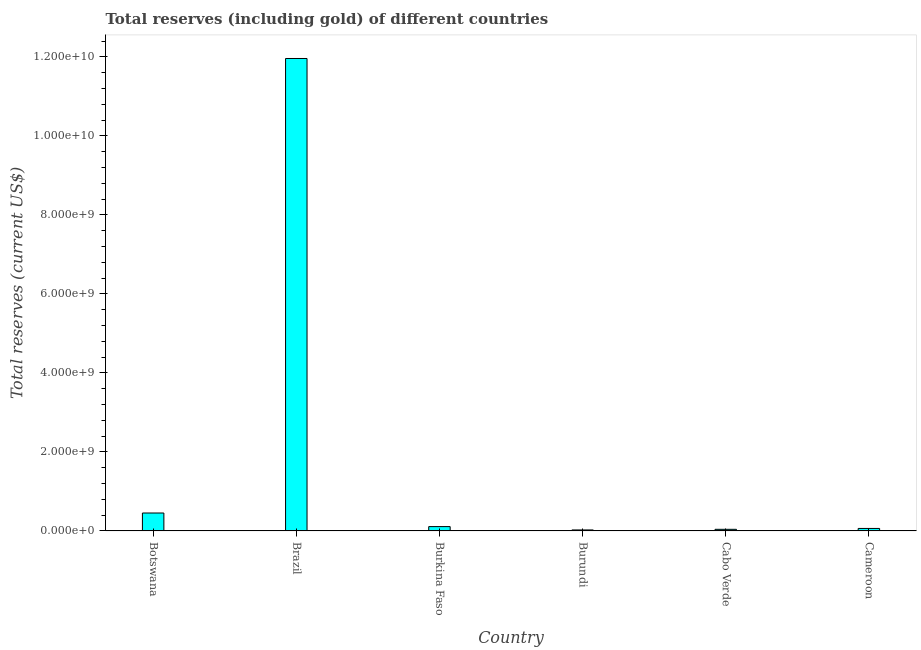Does the graph contain any zero values?
Offer a terse response. No. What is the title of the graph?
Ensure brevity in your answer.  Total reserves (including gold) of different countries. What is the label or title of the X-axis?
Provide a short and direct response. Country. What is the label or title of the Y-axis?
Make the answer very short. Total reserves (current US$). What is the total reserves (including gold) in Burkina Faso?
Keep it short and to the point. 1.10e+08. Across all countries, what is the maximum total reserves (including gold)?
Provide a succinct answer. 1.20e+1. Across all countries, what is the minimum total reserves (including gold)?
Your answer should be very brief. 2.50e+07. In which country was the total reserves (including gold) maximum?
Keep it short and to the point. Brazil. In which country was the total reserves (including gold) minimum?
Ensure brevity in your answer.  Burundi. What is the sum of the total reserves (including gold)?
Your answer should be very brief. 1.27e+1. What is the difference between the total reserves (including gold) in Burkina Faso and Cameroon?
Keep it short and to the point. 4.66e+07. What is the average total reserves (including gold) per country?
Your answer should be compact. 2.11e+09. What is the median total reserves (including gold)?
Your answer should be very brief. 8.64e+07. In how many countries, is the total reserves (including gold) greater than 400000000 US$?
Provide a succinct answer. 2. What is the ratio of the total reserves (including gold) in Burundi to that in Cabo Verde?
Make the answer very short. 0.61. Is the difference between the total reserves (including gold) in Brazil and Cameroon greater than the difference between any two countries?
Keep it short and to the point. No. What is the difference between the highest and the second highest total reserves (including gold)?
Your response must be concise. 1.15e+1. Is the sum of the total reserves (including gold) in Botswana and Cameroon greater than the maximum total reserves (including gold) across all countries?
Keep it short and to the point. No. What is the difference between the highest and the lowest total reserves (including gold)?
Your answer should be very brief. 1.19e+1. In how many countries, is the total reserves (including gold) greater than the average total reserves (including gold) taken over all countries?
Your response must be concise. 1. Are all the bars in the graph horizontal?
Your response must be concise. No. What is the Total reserves (current US$) of Botswana?
Provide a succinct answer. 4.54e+08. What is the Total reserves (current US$) in Brazil?
Offer a terse response. 1.20e+1. What is the Total reserves (current US$) of Burkina Faso?
Make the answer very short. 1.10e+08. What is the Total reserves (current US$) in Burundi?
Your answer should be very brief. 2.50e+07. What is the Total reserves (current US$) of Cabo Verde?
Provide a succinct answer. 4.10e+07. What is the Total reserves (current US$) in Cameroon?
Keep it short and to the point. 6.31e+07. What is the difference between the Total reserves (current US$) in Botswana and Brazil?
Your response must be concise. -1.15e+1. What is the difference between the Total reserves (current US$) in Botswana and Burkina Faso?
Provide a succinct answer. 3.44e+08. What is the difference between the Total reserves (current US$) in Botswana and Burundi?
Keep it short and to the point. 4.29e+08. What is the difference between the Total reserves (current US$) in Botswana and Cabo Verde?
Offer a very short reply. 4.13e+08. What is the difference between the Total reserves (current US$) in Botswana and Cameroon?
Your answer should be very brief. 3.91e+08. What is the difference between the Total reserves (current US$) in Brazil and Burkina Faso?
Your answer should be very brief. 1.19e+1. What is the difference between the Total reserves (current US$) in Brazil and Burundi?
Offer a terse response. 1.19e+1. What is the difference between the Total reserves (current US$) in Brazil and Cabo Verde?
Give a very brief answer. 1.19e+1. What is the difference between the Total reserves (current US$) in Brazil and Cameroon?
Give a very brief answer. 1.19e+1. What is the difference between the Total reserves (current US$) in Burkina Faso and Burundi?
Give a very brief answer. 8.47e+07. What is the difference between the Total reserves (current US$) in Burkina Faso and Cabo Verde?
Provide a succinct answer. 6.87e+07. What is the difference between the Total reserves (current US$) in Burkina Faso and Cameroon?
Give a very brief answer. 4.66e+07. What is the difference between the Total reserves (current US$) in Burundi and Cabo Verde?
Provide a succinct answer. -1.59e+07. What is the difference between the Total reserves (current US$) in Burundi and Cameroon?
Ensure brevity in your answer.  -3.81e+07. What is the difference between the Total reserves (current US$) in Cabo Verde and Cameroon?
Keep it short and to the point. -2.21e+07. What is the ratio of the Total reserves (current US$) in Botswana to that in Brazil?
Give a very brief answer. 0.04. What is the ratio of the Total reserves (current US$) in Botswana to that in Burkina Faso?
Provide a short and direct response. 4.14. What is the ratio of the Total reserves (current US$) in Botswana to that in Burundi?
Offer a very short reply. 18.12. What is the ratio of the Total reserves (current US$) in Botswana to that in Cabo Verde?
Provide a short and direct response. 11.07. What is the ratio of the Total reserves (current US$) in Botswana to that in Cameroon?
Give a very brief answer. 7.19. What is the ratio of the Total reserves (current US$) in Brazil to that in Burkina Faso?
Give a very brief answer. 109. What is the ratio of the Total reserves (current US$) in Brazil to that in Burundi?
Make the answer very short. 477.65. What is the ratio of the Total reserves (current US$) in Brazil to that in Cabo Verde?
Offer a terse response. 291.8. What is the ratio of the Total reserves (current US$) in Brazil to that in Cameroon?
Your answer should be compact. 189.55. What is the ratio of the Total reserves (current US$) in Burkina Faso to that in Burundi?
Provide a short and direct response. 4.38. What is the ratio of the Total reserves (current US$) in Burkina Faso to that in Cabo Verde?
Provide a succinct answer. 2.68. What is the ratio of the Total reserves (current US$) in Burkina Faso to that in Cameroon?
Provide a succinct answer. 1.74. What is the ratio of the Total reserves (current US$) in Burundi to that in Cabo Verde?
Provide a succinct answer. 0.61. What is the ratio of the Total reserves (current US$) in Burundi to that in Cameroon?
Provide a short and direct response. 0.4. What is the ratio of the Total reserves (current US$) in Cabo Verde to that in Cameroon?
Your response must be concise. 0.65. 